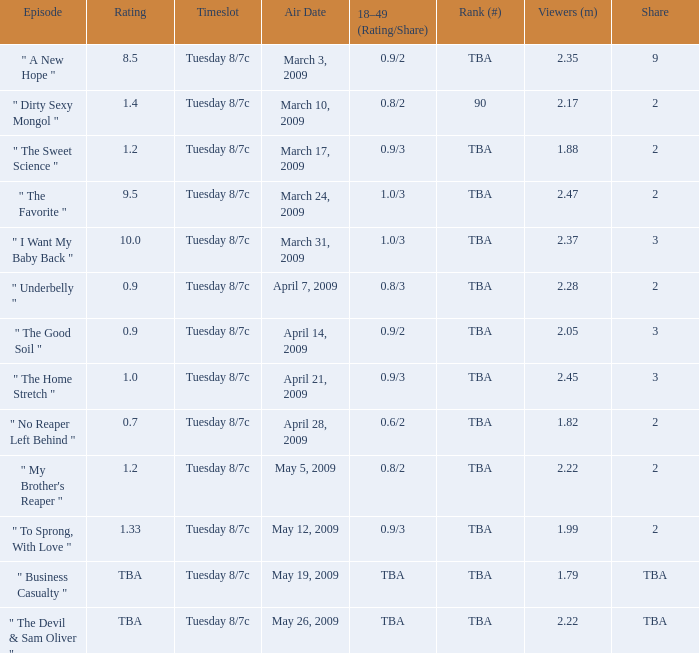What is the rating of the show ranked tba, aired on April 21, 2009? 1.0. 